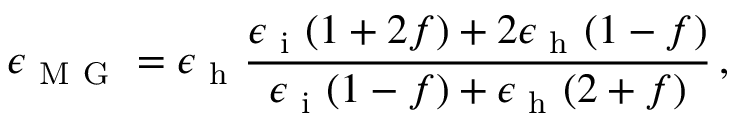<formula> <loc_0><loc_0><loc_500><loc_500>\epsilon _ { M G } = \epsilon _ { h } \frac { \epsilon _ { i } ( 1 + 2 f ) + 2 \epsilon _ { h } ( 1 - f ) } { \epsilon _ { i } ( 1 - f ) + \epsilon _ { h } ( 2 + f ) } \, ,</formula> 